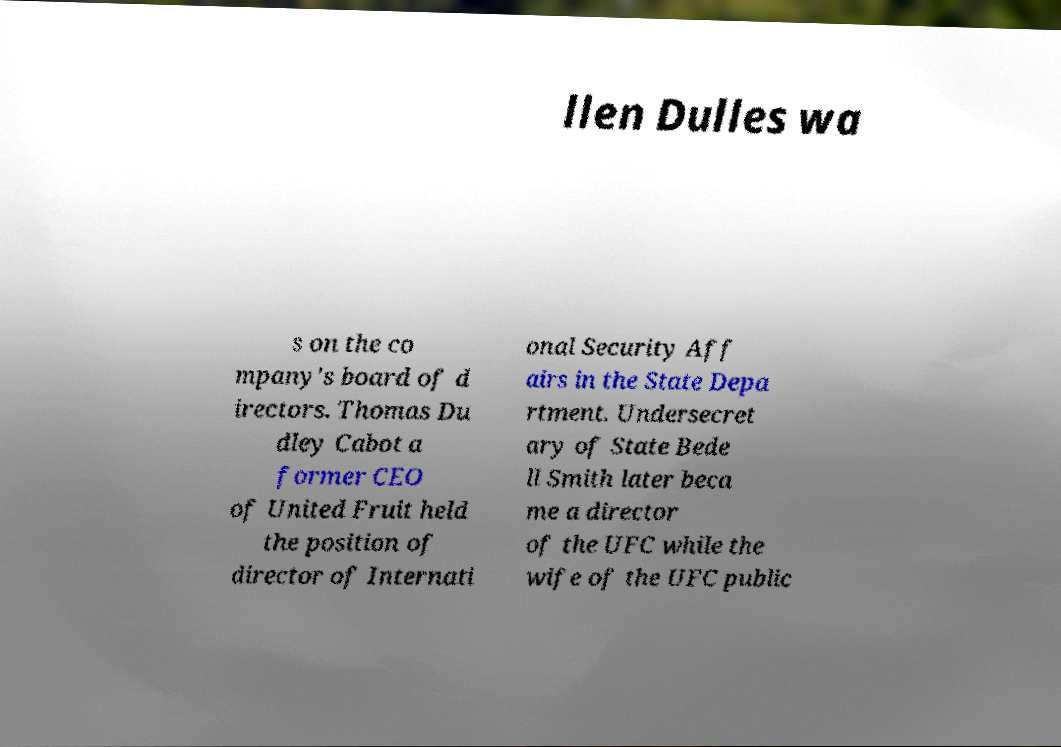There's text embedded in this image that I need extracted. Can you transcribe it verbatim? llen Dulles wa s on the co mpany's board of d irectors. Thomas Du dley Cabot a former CEO of United Fruit held the position of director of Internati onal Security Aff airs in the State Depa rtment. Undersecret ary of State Bede ll Smith later beca me a director of the UFC while the wife of the UFC public 